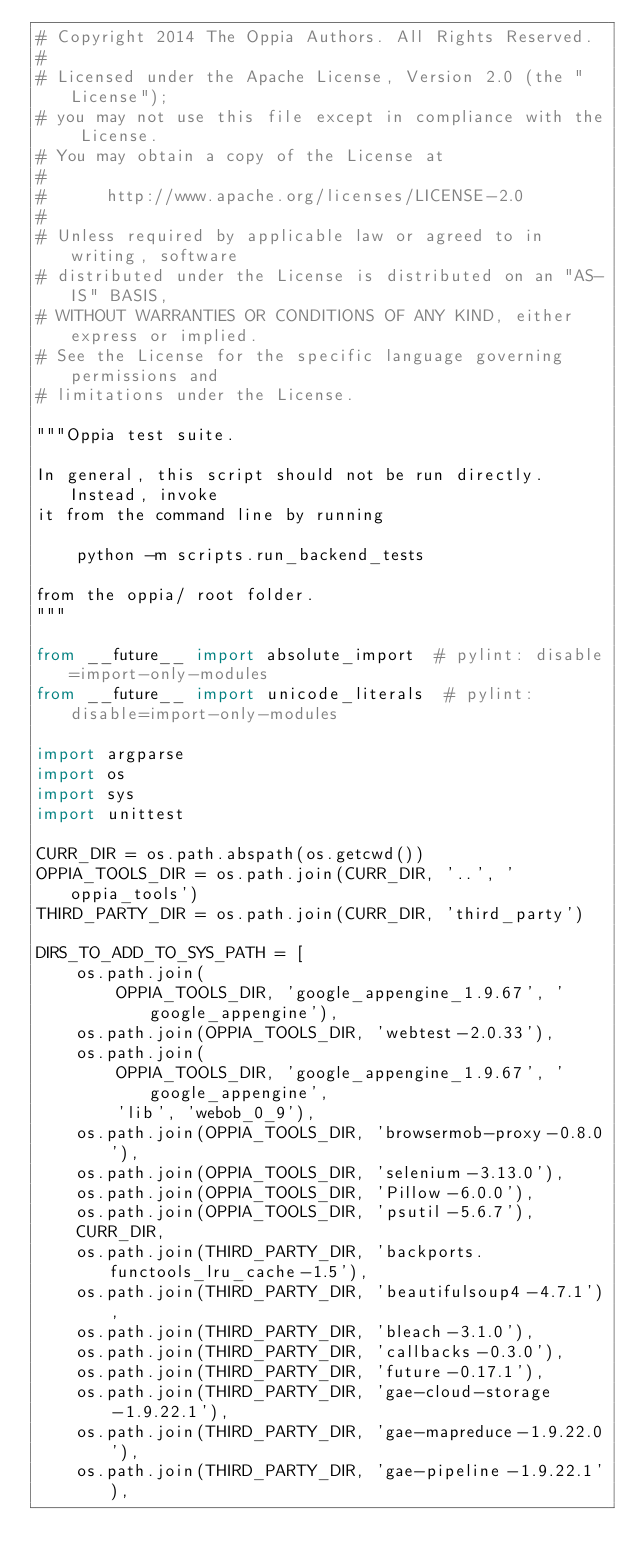<code> <loc_0><loc_0><loc_500><loc_500><_Python_># Copyright 2014 The Oppia Authors. All Rights Reserved.
#
# Licensed under the Apache License, Version 2.0 (the "License");
# you may not use this file except in compliance with the License.
# You may obtain a copy of the License at
#
#      http://www.apache.org/licenses/LICENSE-2.0
#
# Unless required by applicable law or agreed to in writing, software
# distributed under the License is distributed on an "AS-IS" BASIS,
# WITHOUT WARRANTIES OR CONDITIONS OF ANY KIND, either express or implied.
# See the License for the specific language governing permissions and
# limitations under the License.

"""Oppia test suite.

In general, this script should not be run directly. Instead, invoke
it from the command line by running

    python -m scripts.run_backend_tests

from the oppia/ root folder.
"""

from __future__ import absolute_import  # pylint: disable=import-only-modules
from __future__ import unicode_literals  # pylint: disable=import-only-modules

import argparse
import os
import sys
import unittest

CURR_DIR = os.path.abspath(os.getcwd())
OPPIA_TOOLS_DIR = os.path.join(CURR_DIR, '..', 'oppia_tools')
THIRD_PARTY_DIR = os.path.join(CURR_DIR, 'third_party')

DIRS_TO_ADD_TO_SYS_PATH = [
    os.path.join(
        OPPIA_TOOLS_DIR, 'google_appengine_1.9.67', 'google_appengine'),
    os.path.join(OPPIA_TOOLS_DIR, 'webtest-2.0.33'),
    os.path.join(
        OPPIA_TOOLS_DIR, 'google_appengine_1.9.67', 'google_appengine',
        'lib', 'webob_0_9'),
    os.path.join(OPPIA_TOOLS_DIR, 'browsermob-proxy-0.8.0'),
    os.path.join(OPPIA_TOOLS_DIR, 'selenium-3.13.0'),
    os.path.join(OPPIA_TOOLS_DIR, 'Pillow-6.0.0'),
    os.path.join(OPPIA_TOOLS_DIR, 'psutil-5.6.7'),
    CURR_DIR,
    os.path.join(THIRD_PARTY_DIR, 'backports.functools_lru_cache-1.5'),
    os.path.join(THIRD_PARTY_DIR, 'beautifulsoup4-4.7.1'),
    os.path.join(THIRD_PARTY_DIR, 'bleach-3.1.0'),
    os.path.join(THIRD_PARTY_DIR, 'callbacks-0.3.0'),
    os.path.join(THIRD_PARTY_DIR, 'future-0.17.1'),
    os.path.join(THIRD_PARTY_DIR, 'gae-cloud-storage-1.9.22.1'),
    os.path.join(THIRD_PARTY_DIR, 'gae-mapreduce-1.9.22.0'),
    os.path.join(THIRD_PARTY_DIR, 'gae-pipeline-1.9.22.1'),</code> 